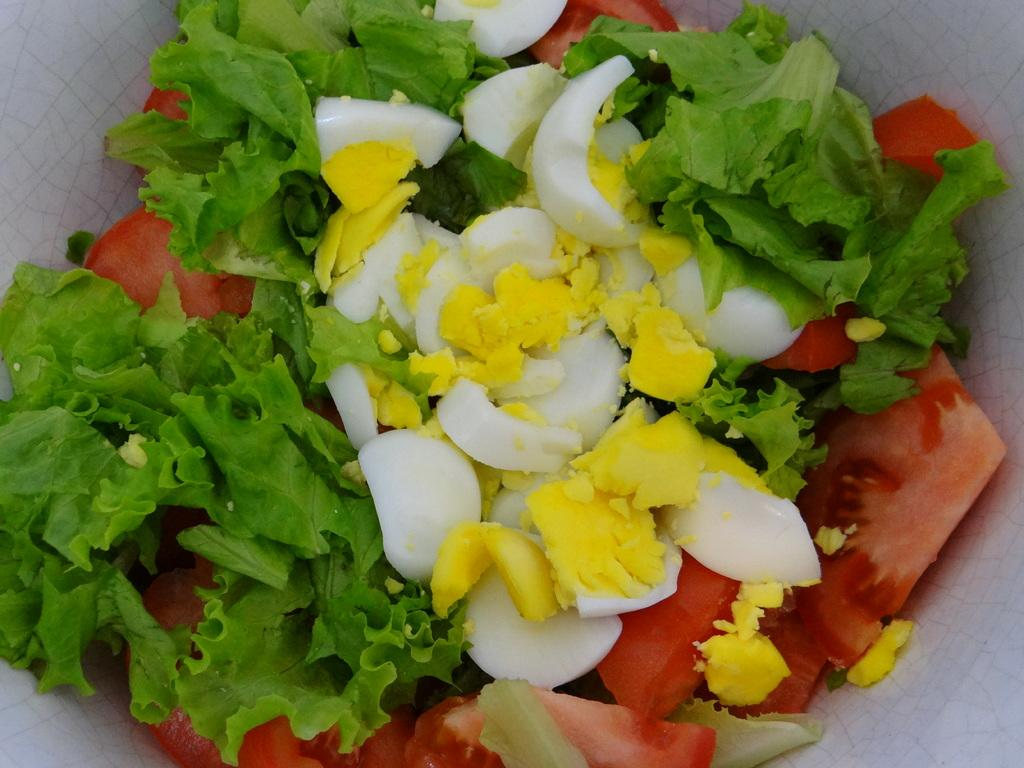What is the main subject of the image? The main subject of the image is a bowl containing various elements. What is one of the elements visible in the bowl? There is a crushed egg in the image. What other food items can be seen in the bowl? There are pieces of tomato in the image. Are there any non-food items visible in the bowl? Yes, there are vegetable leaves in the image. What is the queen's reaction to the crushed egg in the image? There is no queen present in the image, and therefore her reaction cannot be determined. 